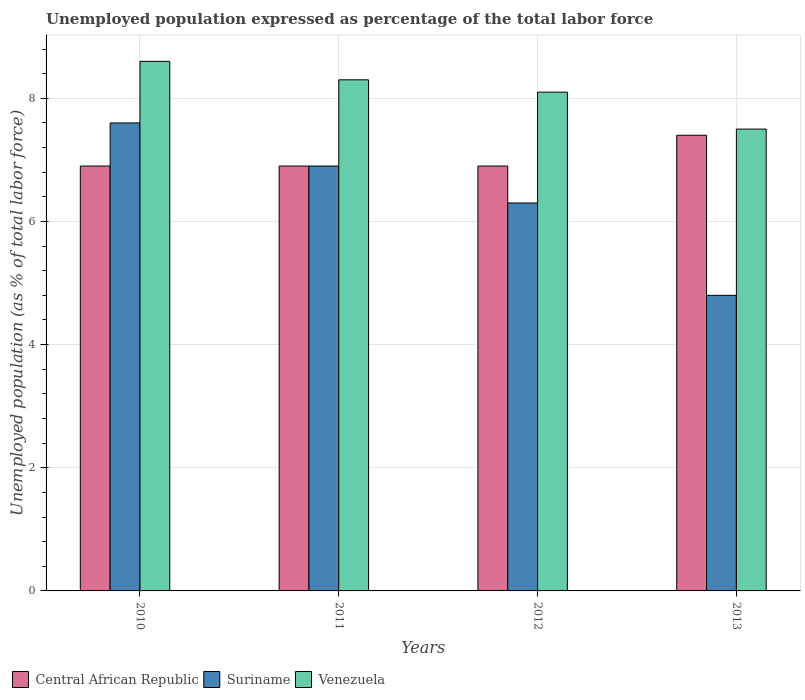How many bars are there on the 3rd tick from the left?
Ensure brevity in your answer.  3. What is the label of the 3rd group of bars from the left?
Your answer should be very brief. 2012. What is the unemployment in in Suriname in 2012?
Keep it short and to the point. 6.3. Across all years, what is the maximum unemployment in in Venezuela?
Make the answer very short. 8.6. In which year was the unemployment in in Central African Republic maximum?
Your answer should be very brief. 2013. What is the total unemployment in in Central African Republic in the graph?
Your response must be concise. 28.1. What is the difference between the unemployment in in Central African Republic in 2010 and the unemployment in in Venezuela in 2012?
Offer a very short reply. -1.2. What is the average unemployment in in Central African Republic per year?
Your answer should be compact. 7.03. In the year 2010, what is the difference between the unemployment in in Venezuela and unemployment in in Suriname?
Your answer should be compact. 1. In how many years, is the unemployment in in Suriname greater than 2 %?
Provide a succinct answer. 4. What is the ratio of the unemployment in in Venezuela in 2010 to that in 2013?
Your answer should be compact. 1.15. Is the difference between the unemployment in in Venezuela in 2011 and 2012 greater than the difference between the unemployment in in Suriname in 2011 and 2012?
Provide a short and direct response. No. What is the difference between the highest and the second highest unemployment in in Venezuela?
Ensure brevity in your answer.  0.3. Is the sum of the unemployment in in Suriname in 2012 and 2013 greater than the maximum unemployment in in Venezuela across all years?
Provide a succinct answer. Yes. What does the 3rd bar from the left in 2013 represents?
Offer a very short reply. Venezuela. What does the 3rd bar from the right in 2013 represents?
Your response must be concise. Central African Republic. How many bars are there?
Your answer should be very brief. 12. How many years are there in the graph?
Provide a succinct answer. 4. What is the difference between two consecutive major ticks on the Y-axis?
Give a very brief answer. 2. Are the values on the major ticks of Y-axis written in scientific E-notation?
Provide a succinct answer. No. Does the graph contain any zero values?
Give a very brief answer. No. Does the graph contain grids?
Offer a terse response. Yes. What is the title of the graph?
Offer a very short reply. Unemployed population expressed as percentage of the total labor force. Does "Small states" appear as one of the legend labels in the graph?
Give a very brief answer. No. What is the label or title of the Y-axis?
Your answer should be very brief. Unemployed population (as % of total labor force). What is the Unemployed population (as % of total labor force) of Central African Republic in 2010?
Ensure brevity in your answer.  6.9. What is the Unemployed population (as % of total labor force) of Suriname in 2010?
Your response must be concise. 7.6. What is the Unemployed population (as % of total labor force) of Venezuela in 2010?
Provide a succinct answer. 8.6. What is the Unemployed population (as % of total labor force) in Central African Republic in 2011?
Your answer should be compact. 6.9. What is the Unemployed population (as % of total labor force) of Suriname in 2011?
Your answer should be very brief. 6.9. What is the Unemployed population (as % of total labor force) of Venezuela in 2011?
Your answer should be very brief. 8.3. What is the Unemployed population (as % of total labor force) in Central African Republic in 2012?
Keep it short and to the point. 6.9. What is the Unemployed population (as % of total labor force) in Suriname in 2012?
Keep it short and to the point. 6.3. What is the Unemployed population (as % of total labor force) of Venezuela in 2012?
Keep it short and to the point. 8.1. What is the Unemployed population (as % of total labor force) in Central African Republic in 2013?
Ensure brevity in your answer.  7.4. What is the Unemployed population (as % of total labor force) in Suriname in 2013?
Make the answer very short. 4.8. Across all years, what is the maximum Unemployed population (as % of total labor force) in Central African Republic?
Ensure brevity in your answer.  7.4. Across all years, what is the maximum Unemployed population (as % of total labor force) in Suriname?
Make the answer very short. 7.6. Across all years, what is the maximum Unemployed population (as % of total labor force) of Venezuela?
Your answer should be compact. 8.6. Across all years, what is the minimum Unemployed population (as % of total labor force) of Central African Republic?
Ensure brevity in your answer.  6.9. Across all years, what is the minimum Unemployed population (as % of total labor force) in Suriname?
Your response must be concise. 4.8. Across all years, what is the minimum Unemployed population (as % of total labor force) of Venezuela?
Provide a short and direct response. 7.5. What is the total Unemployed population (as % of total labor force) of Central African Republic in the graph?
Your response must be concise. 28.1. What is the total Unemployed population (as % of total labor force) of Suriname in the graph?
Provide a short and direct response. 25.6. What is the total Unemployed population (as % of total labor force) in Venezuela in the graph?
Your response must be concise. 32.5. What is the difference between the Unemployed population (as % of total labor force) in Central African Republic in 2010 and that in 2011?
Make the answer very short. 0. What is the difference between the Unemployed population (as % of total labor force) in Suriname in 2010 and that in 2011?
Offer a very short reply. 0.7. What is the difference between the Unemployed population (as % of total labor force) in Venezuela in 2010 and that in 2011?
Provide a succinct answer. 0.3. What is the difference between the Unemployed population (as % of total labor force) of Venezuela in 2010 and that in 2012?
Your answer should be compact. 0.5. What is the difference between the Unemployed population (as % of total labor force) in Suriname in 2011 and that in 2012?
Provide a short and direct response. 0.6. What is the difference between the Unemployed population (as % of total labor force) of Venezuela in 2011 and that in 2012?
Give a very brief answer. 0.2. What is the difference between the Unemployed population (as % of total labor force) of Venezuela in 2011 and that in 2013?
Keep it short and to the point. 0.8. What is the difference between the Unemployed population (as % of total labor force) of Central African Republic in 2012 and that in 2013?
Give a very brief answer. -0.5. What is the difference between the Unemployed population (as % of total labor force) of Suriname in 2012 and that in 2013?
Your response must be concise. 1.5. What is the difference between the Unemployed population (as % of total labor force) of Venezuela in 2012 and that in 2013?
Make the answer very short. 0.6. What is the difference between the Unemployed population (as % of total labor force) in Central African Republic in 2010 and the Unemployed population (as % of total labor force) in Venezuela in 2011?
Keep it short and to the point. -1.4. What is the difference between the Unemployed population (as % of total labor force) in Suriname in 2010 and the Unemployed population (as % of total labor force) in Venezuela in 2011?
Your answer should be compact. -0.7. What is the difference between the Unemployed population (as % of total labor force) in Suriname in 2010 and the Unemployed population (as % of total labor force) in Venezuela in 2012?
Your answer should be very brief. -0.5. What is the difference between the Unemployed population (as % of total labor force) of Central African Republic in 2010 and the Unemployed population (as % of total labor force) of Suriname in 2013?
Offer a terse response. 2.1. What is the difference between the Unemployed population (as % of total labor force) of Central African Republic in 2011 and the Unemployed population (as % of total labor force) of Suriname in 2012?
Your answer should be very brief. 0.6. What is the difference between the Unemployed population (as % of total labor force) in Central African Republic in 2011 and the Unemployed population (as % of total labor force) in Venezuela in 2012?
Make the answer very short. -1.2. What is the difference between the Unemployed population (as % of total labor force) in Central African Republic in 2011 and the Unemployed population (as % of total labor force) in Venezuela in 2013?
Offer a very short reply. -0.6. What is the difference between the Unemployed population (as % of total labor force) in Central African Republic in 2012 and the Unemployed population (as % of total labor force) in Suriname in 2013?
Provide a short and direct response. 2.1. What is the difference between the Unemployed population (as % of total labor force) in Central African Republic in 2012 and the Unemployed population (as % of total labor force) in Venezuela in 2013?
Give a very brief answer. -0.6. What is the average Unemployed population (as % of total labor force) in Central African Republic per year?
Ensure brevity in your answer.  7.03. What is the average Unemployed population (as % of total labor force) in Suriname per year?
Keep it short and to the point. 6.4. What is the average Unemployed population (as % of total labor force) of Venezuela per year?
Give a very brief answer. 8.12. In the year 2010, what is the difference between the Unemployed population (as % of total labor force) of Suriname and Unemployed population (as % of total labor force) of Venezuela?
Your answer should be very brief. -1. In the year 2011, what is the difference between the Unemployed population (as % of total labor force) in Central African Republic and Unemployed population (as % of total labor force) in Venezuela?
Give a very brief answer. -1.4. In the year 2011, what is the difference between the Unemployed population (as % of total labor force) in Suriname and Unemployed population (as % of total labor force) in Venezuela?
Keep it short and to the point. -1.4. In the year 2012, what is the difference between the Unemployed population (as % of total labor force) in Central African Republic and Unemployed population (as % of total labor force) in Suriname?
Provide a short and direct response. 0.6. In the year 2012, what is the difference between the Unemployed population (as % of total labor force) in Central African Republic and Unemployed population (as % of total labor force) in Venezuela?
Your answer should be very brief. -1.2. What is the ratio of the Unemployed population (as % of total labor force) in Central African Republic in 2010 to that in 2011?
Give a very brief answer. 1. What is the ratio of the Unemployed population (as % of total labor force) in Suriname in 2010 to that in 2011?
Offer a terse response. 1.1. What is the ratio of the Unemployed population (as % of total labor force) in Venezuela in 2010 to that in 2011?
Keep it short and to the point. 1.04. What is the ratio of the Unemployed population (as % of total labor force) of Suriname in 2010 to that in 2012?
Your answer should be very brief. 1.21. What is the ratio of the Unemployed population (as % of total labor force) of Venezuela in 2010 to that in 2012?
Your response must be concise. 1.06. What is the ratio of the Unemployed population (as % of total labor force) of Central African Republic in 2010 to that in 2013?
Offer a very short reply. 0.93. What is the ratio of the Unemployed population (as % of total labor force) in Suriname in 2010 to that in 2013?
Provide a short and direct response. 1.58. What is the ratio of the Unemployed population (as % of total labor force) in Venezuela in 2010 to that in 2013?
Ensure brevity in your answer.  1.15. What is the ratio of the Unemployed population (as % of total labor force) in Central African Republic in 2011 to that in 2012?
Ensure brevity in your answer.  1. What is the ratio of the Unemployed population (as % of total labor force) in Suriname in 2011 to that in 2012?
Provide a short and direct response. 1.1. What is the ratio of the Unemployed population (as % of total labor force) in Venezuela in 2011 to that in 2012?
Keep it short and to the point. 1.02. What is the ratio of the Unemployed population (as % of total labor force) in Central African Republic in 2011 to that in 2013?
Keep it short and to the point. 0.93. What is the ratio of the Unemployed population (as % of total labor force) of Suriname in 2011 to that in 2013?
Provide a succinct answer. 1.44. What is the ratio of the Unemployed population (as % of total labor force) in Venezuela in 2011 to that in 2013?
Provide a short and direct response. 1.11. What is the ratio of the Unemployed population (as % of total labor force) of Central African Republic in 2012 to that in 2013?
Make the answer very short. 0.93. What is the ratio of the Unemployed population (as % of total labor force) of Suriname in 2012 to that in 2013?
Give a very brief answer. 1.31. What is the ratio of the Unemployed population (as % of total labor force) in Venezuela in 2012 to that in 2013?
Make the answer very short. 1.08. What is the difference between the highest and the second highest Unemployed population (as % of total labor force) of Central African Republic?
Offer a terse response. 0.5. What is the difference between the highest and the second highest Unemployed population (as % of total labor force) of Venezuela?
Offer a very short reply. 0.3. What is the difference between the highest and the lowest Unemployed population (as % of total labor force) in Suriname?
Ensure brevity in your answer.  2.8. What is the difference between the highest and the lowest Unemployed population (as % of total labor force) in Venezuela?
Keep it short and to the point. 1.1. 